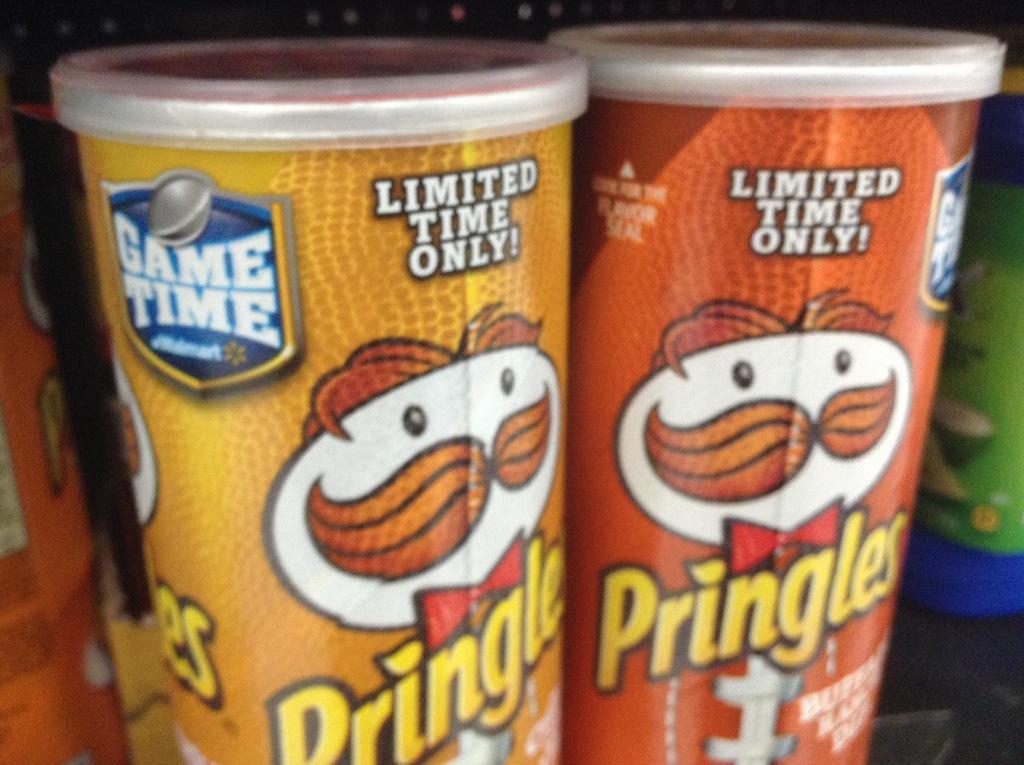These chips are available how long?
Your response must be concise. Limited time. These chips are advertised for what kind of time?
Offer a terse response. Limited. 